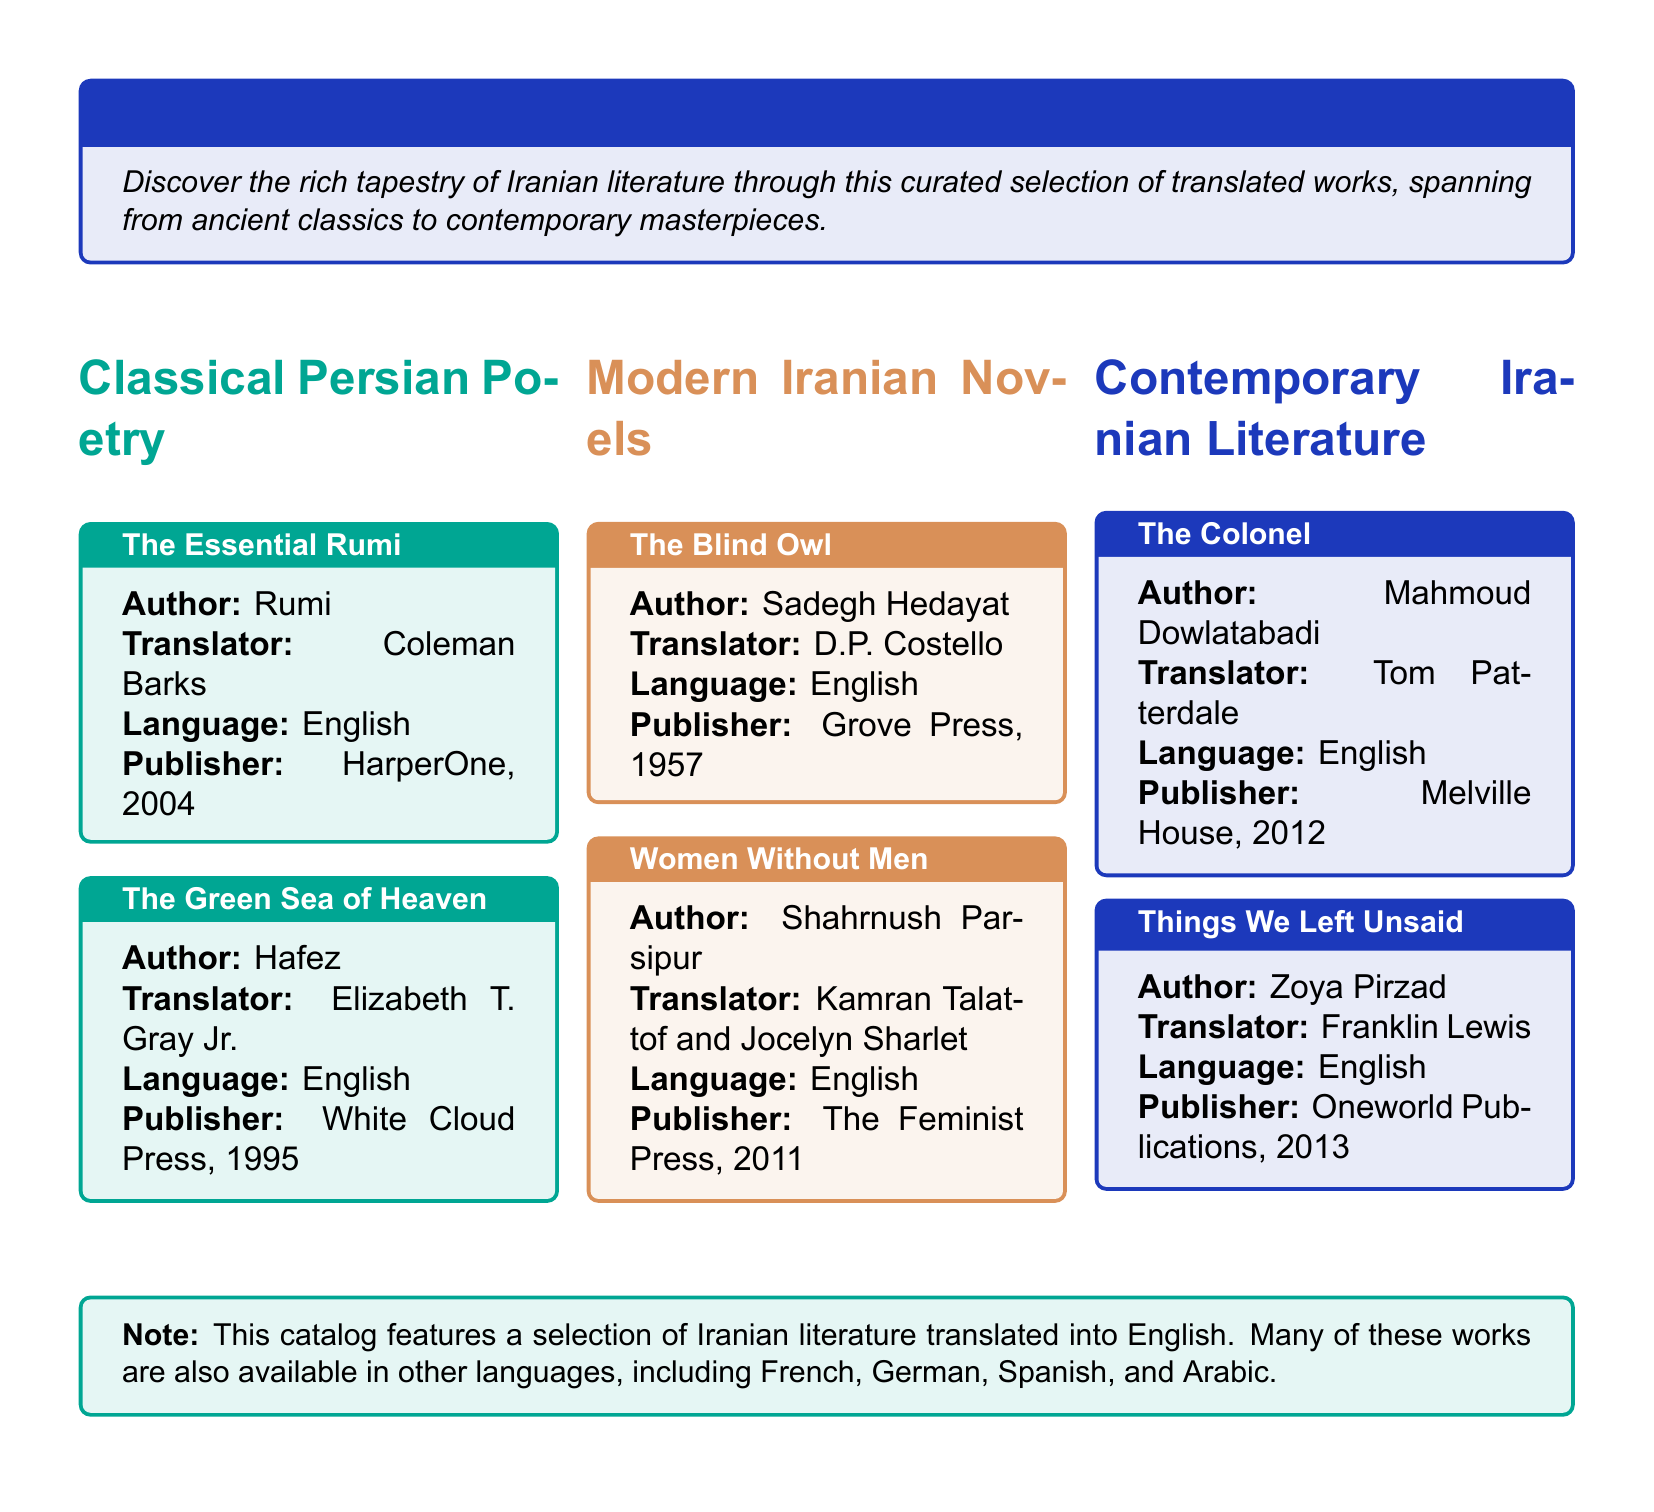What is the first title in the Classical Persian Poetry section? The question seeks the name of the first listed work in the Classical Persian Poetry section of the catalog.
Answer: The Essential Rumi Who is the translator of "The Blind Owl"? This question identifies the translator for the specific modern novel listed in the catalog.
Answer: D.P. Costello What year was "Women Without Men" published? This question asks for the publication year of the specified modern Iranian novel.
Answer: 2011 Which author is associated with the work "Things We Left Unsaid"? The question inquires about the author of the contemporary literature piece mentioned.
Answer: Zoya Pirzad What language is predominantly featured in this catalog? This question assesses the main language of the translations highlighted in the document.
Answer: English How many sections are in the catalog? The question looks for the total number of distinct sections present in the document.
Answer: Three What publisher released "The Essential Rumi"? This question seeks the name of the publisher responsible for the edition of this classic work.
Answer: HarperOne Which section does "The Colonel" belong to? The question categorizes the specified work under one of the major sections listed in the catalog.
Answer: Contemporary Iranian Literature 